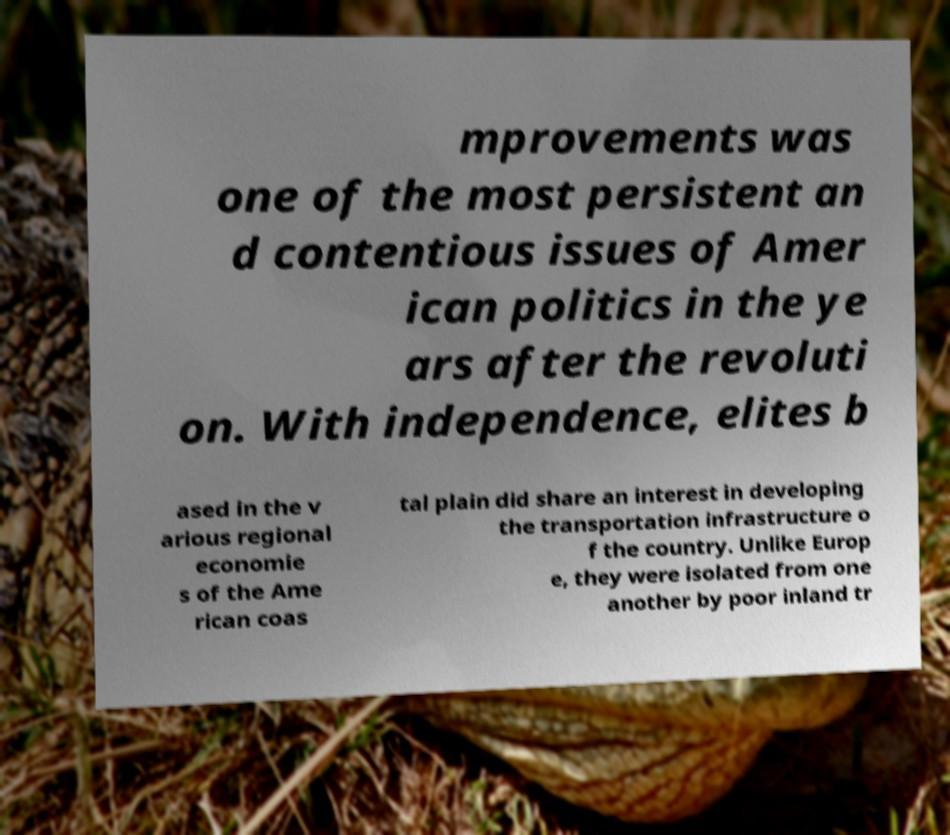Can you accurately transcribe the text from the provided image for me? mprovements was one of the most persistent an d contentious issues of Amer ican politics in the ye ars after the revoluti on. With independence, elites b ased in the v arious regional economie s of the Ame rican coas tal plain did share an interest in developing the transportation infrastructure o f the country. Unlike Europ e, they were isolated from one another by poor inland tr 